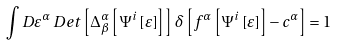Convert formula to latex. <formula><loc_0><loc_0><loc_500><loc_500>\int D \varepsilon ^ { \alpha } \, D e t \left [ \Delta _ { \beta } ^ { \alpha } \left [ \Psi ^ { i } \left [ \varepsilon \right ] \right ] \right ] \, \delta \left [ f ^ { \alpha } \left [ \Psi ^ { i } \left [ \varepsilon \right ] \right ] - c ^ { \alpha } \right ] = 1</formula> 